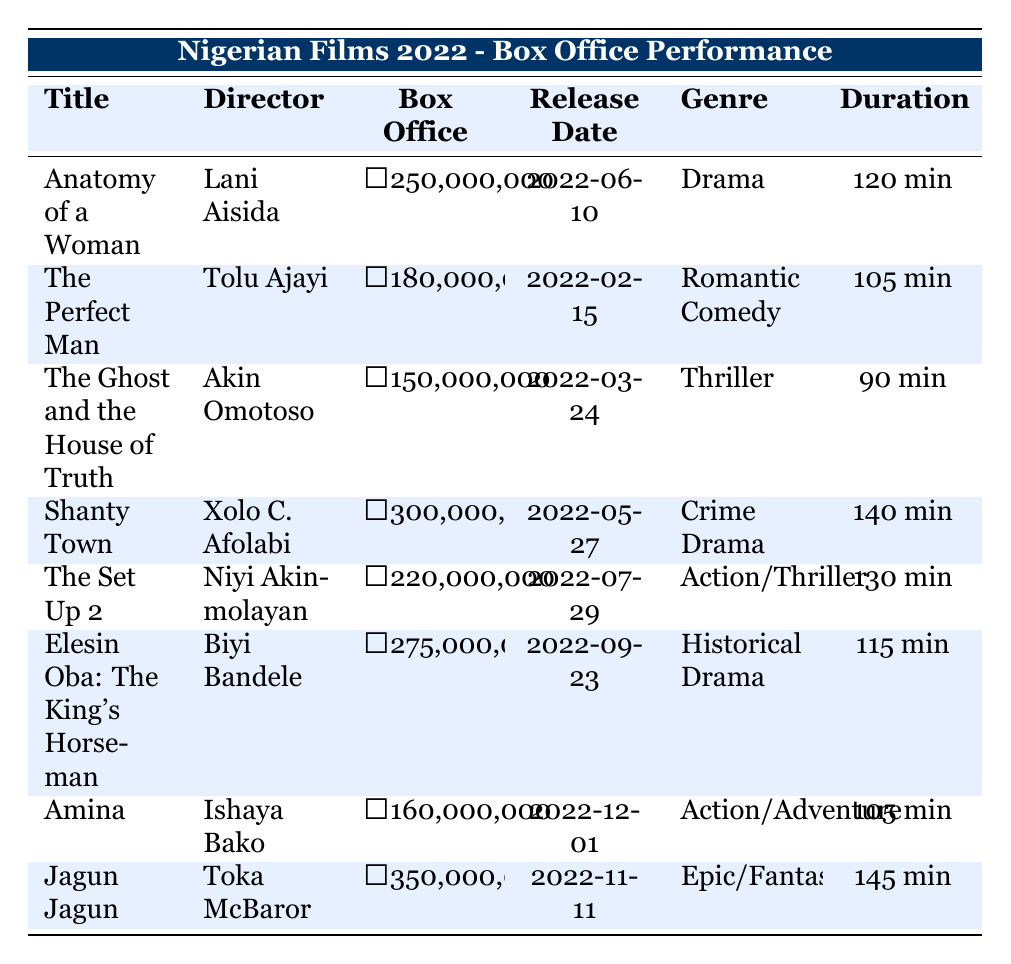What is the highest box office gross among Nigerian films in 2022? By looking at the "Box Office" column, the highest value can be identified. The films are listed as follows: ₦250,000,000 for "Anatomy of a Woman", ₦180,000,000 for "The Perfect Man", ₦150,000,000 for "The Ghost and the House of Truth", ₦300,000,000 for "Shanty Town", ₦220,000,000 for "The Set Up 2", ₦275,000,000 for "Elesin Oba: The King's Horseman", ₦160,000,000 for "Amina", and ₦350,000,000 for "Jagun Jagun". The highest value is ₦350,000,000.
Answer: ₦350,000,000 Which film had the longest duration? The "Duration" column lists the lengths of each film. By comparing the durations of "Anatomy of a Woman" (120 min), "The Perfect Man" (105 min), "The Ghost and the House of Truth" (90 min), "Shanty Town" (140 min), "The Set Up 2" (130 min), "Elesin Oba: The King's Horseman" (115 min), "Amina" (105 min), and "Jagun Jagun" (145 min), it is clear that "Jagun Jagun" has the longest duration at 145 minutes.
Answer: 145 min How many films grossed over ₦200,000,000? To find the number of films grossing over ₦200,000,000, we can check the "Box Office" values: "Shanty Town" (₦300,000,000), "Jagun Jagun" (₦350,000,000), "Elesin Oba: The King's Horseman" (₦275,000,000), and "The Set Up 2" (₦220,000,000) fit this criterion. There are a total of four films with box office gross exceeding ₦200,000,000.
Answer: 4 What is the genre of the film directed by Lani Aisida? By locating "Anatomy of a Woman" in the table, we can see that it is directed by Lani Aisida. The corresponding genre in the table is "Drama".
Answer: Drama Is "Shanty Town" longer than "The Perfect Man"? The durations are listed as 140 minutes for "Shanty Town" and 105 minutes for "The Perfect Man". 140 is greater than 105, so "Shanty Town" is indeed longer than "The Perfect Man".
Answer: Yes What was the box office gross of "The Ghost and the House of Truth"? We can find this film in the table and check the "Box Office" column, which shows that the gross was ₦150,000,000.
Answer: ₦150,000,000 Which film had the earliest release date? The release dates need to be compared: "The Perfect Man" (2022-02-15), "The Ghost and the House of Truth" (2022-03-24), "Shanty Town" (2022-05-27), "Anatomy of a Woman" (2022-06-10), "The Set Up 2" (2022-07-29), "Elesin Oba: The King's Horseman" (2022-09-23), "Amina" (2022-12-01), and "Jagun Jagun" (2022-11-11). The earliest date is for "The Perfect Man".
Answer: The Perfect Man How much more did "Jagun Jagun" earn compared to "Elesin Oba: The King's Horseman"? "Jagun Jagun" grossed ₦350,000,000 while "Elesin Oba: The King's Horseman" grossed ₦275,000,000. To find the difference, subtract: ₦350,000,000 - ₦275,000,000 = ₦75,000,000.
Answer: ₦75,000,000 